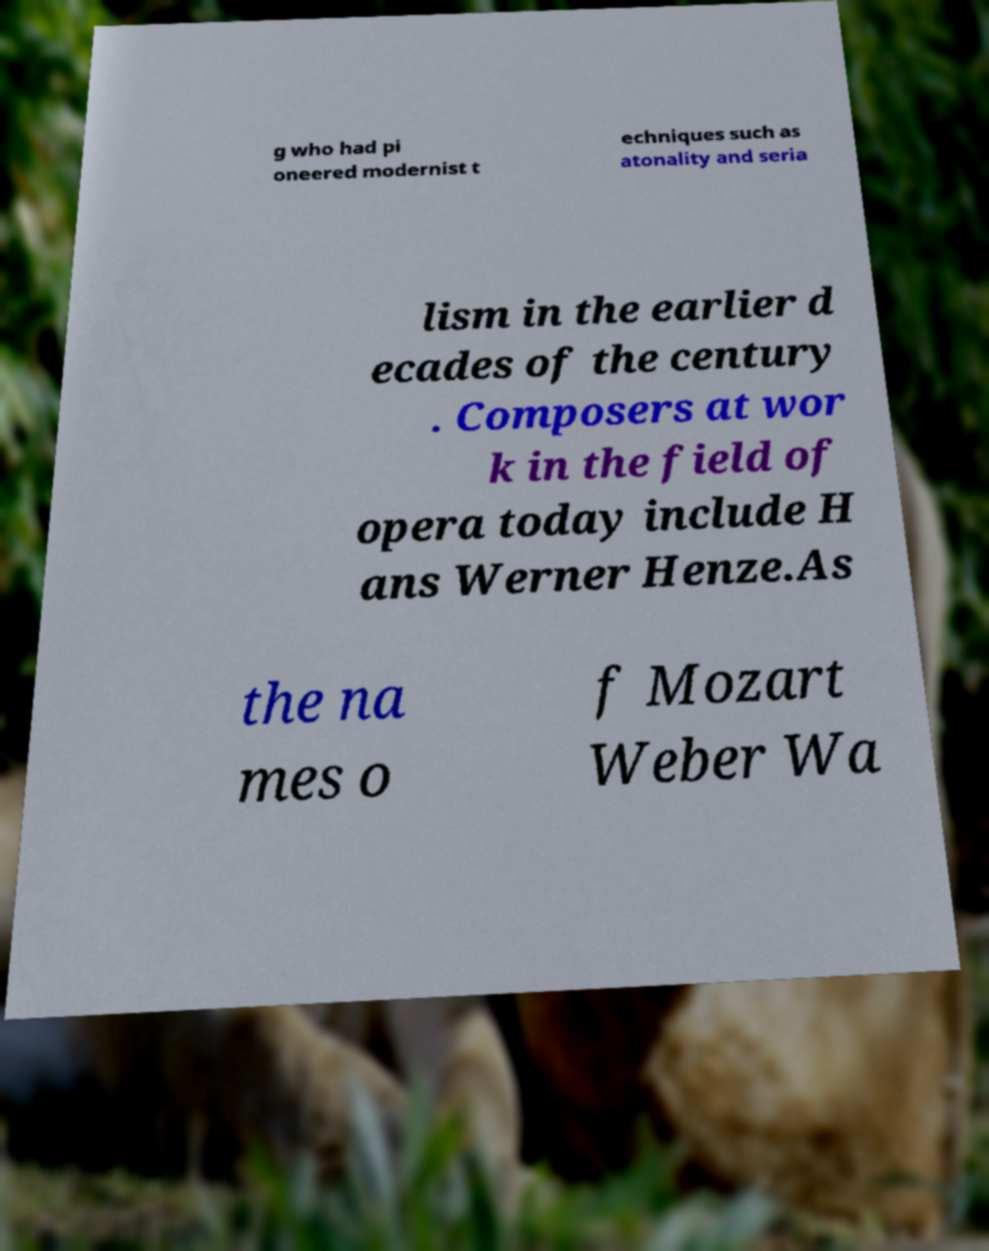What messages or text are displayed in this image? I need them in a readable, typed format. g who had pi oneered modernist t echniques such as atonality and seria lism in the earlier d ecades of the century . Composers at wor k in the field of opera today include H ans Werner Henze.As the na mes o f Mozart Weber Wa 